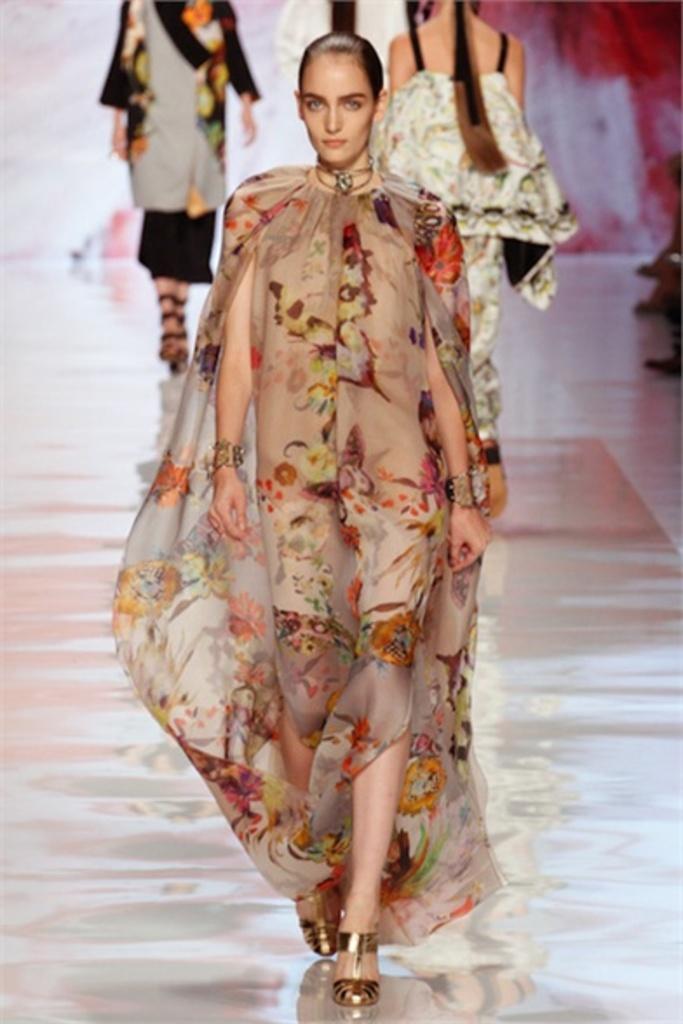Could you give a brief overview of what you see in this image? In this image there is a woman walking on the ramp, behind the women there are three other women. 